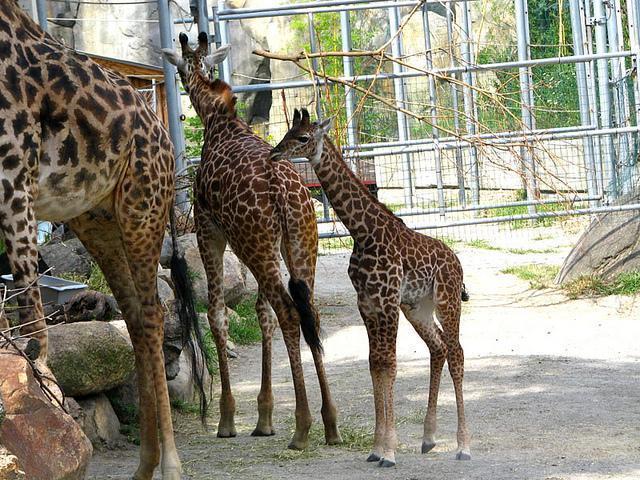How many baby giraffes are there?
Give a very brief answer. 1. How many giraffes can you see?
Give a very brief answer. 3. 